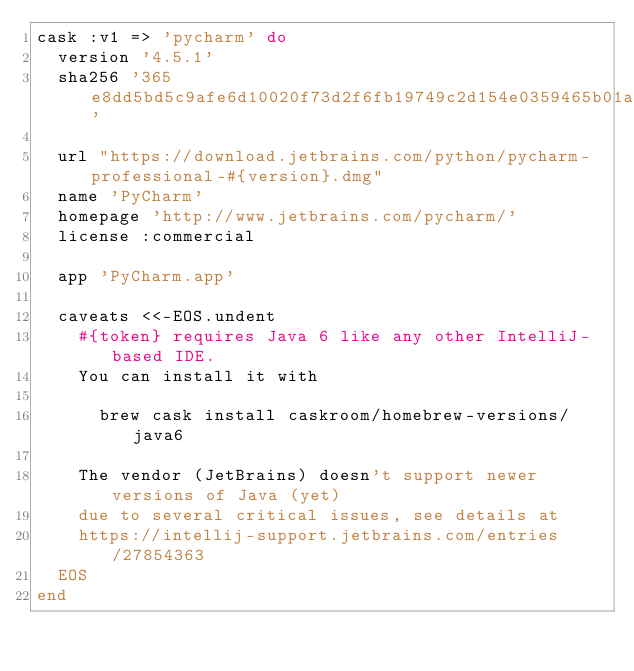<code> <loc_0><loc_0><loc_500><loc_500><_Ruby_>cask :v1 => 'pycharm' do
  version '4.5.1'
  sha256 '365e8dd5bd5c9afe6d10020f73d2f6fb19749c2d154e0359465b01ab27ffecae'

  url "https://download.jetbrains.com/python/pycharm-professional-#{version}.dmg"
  name 'PyCharm'
  homepage 'http://www.jetbrains.com/pycharm/'
  license :commercial

  app 'PyCharm.app'

  caveats <<-EOS.undent
    #{token} requires Java 6 like any other IntelliJ-based IDE.
    You can install it with

      brew cask install caskroom/homebrew-versions/java6

    The vendor (JetBrains) doesn't support newer versions of Java (yet)
    due to several critical issues, see details at
    https://intellij-support.jetbrains.com/entries/27854363
  EOS
end
</code> 